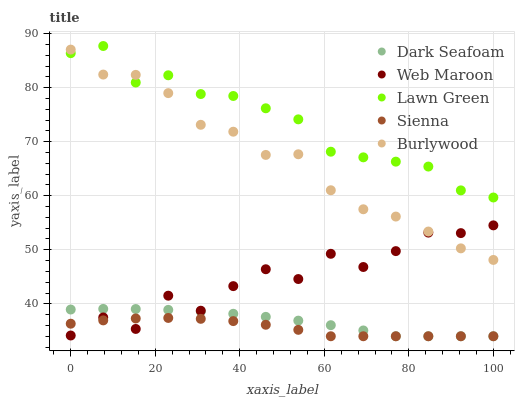Does Sienna have the minimum area under the curve?
Answer yes or no. Yes. Does Lawn Green have the maximum area under the curve?
Answer yes or no. Yes. Does Dark Seafoam have the minimum area under the curve?
Answer yes or no. No. Does Dark Seafoam have the maximum area under the curve?
Answer yes or no. No. Is Dark Seafoam the smoothest?
Answer yes or no. Yes. Is Web Maroon the roughest?
Answer yes or no. Yes. Is Lawn Green the smoothest?
Answer yes or no. No. Is Lawn Green the roughest?
Answer yes or no. No. Does Sienna have the lowest value?
Answer yes or no. Yes. Does Lawn Green have the lowest value?
Answer yes or no. No. Does Lawn Green have the highest value?
Answer yes or no. Yes. Does Dark Seafoam have the highest value?
Answer yes or no. No. Is Sienna less than Burlywood?
Answer yes or no. Yes. Is Burlywood greater than Dark Seafoam?
Answer yes or no. Yes. Does Dark Seafoam intersect Web Maroon?
Answer yes or no. Yes. Is Dark Seafoam less than Web Maroon?
Answer yes or no. No. Is Dark Seafoam greater than Web Maroon?
Answer yes or no. No. Does Sienna intersect Burlywood?
Answer yes or no. No. 